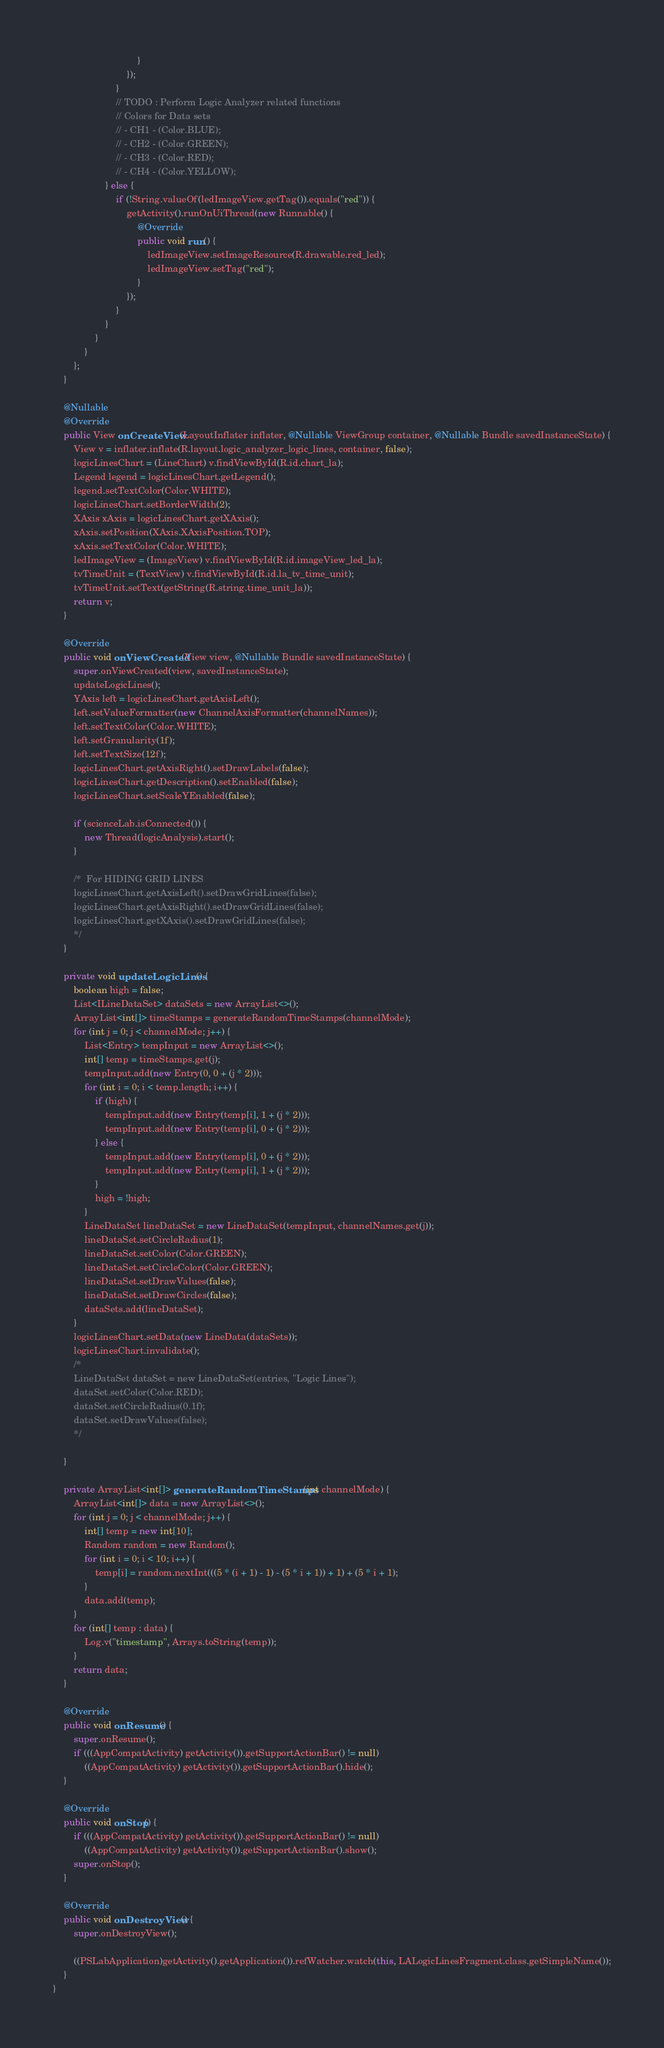<code> <loc_0><loc_0><loc_500><loc_500><_Java_>                                }
                            });
                        }
                        // TODO : Perform Logic Analyzer related functions
                        // Colors for Data sets
                        // - CH1 - (Color.BLUE);
                        // - CH2 - (Color.GREEN);
                        // - CH3 - (Color.RED);
                        // - CH4 - (Color.YELLOW);
                    } else {
                        if (!String.valueOf(ledImageView.getTag()).equals("red")) {
                            getActivity().runOnUiThread(new Runnable() {
                                @Override
                                public void run() {
                                    ledImageView.setImageResource(R.drawable.red_led);
                                    ledImageView.setTag("red");
                                }
                            });
                        }
                    }
                }
            }
        };
    }

    @Nullable
    @Override
    public View onCreateView(LayoutInflater inflater, @Nullable ViewGroup container, @Nullable Bundle savedInstanceState) {
        View v = inflater.inflate(R.layout.logic_analyzer_logic_lines, container, false);
        logicLinesChart = (LineChart) v.findViewById(R.id.chart_la);
        Legend legend = logicLinesChart.getLegend();
        legend.setTextColor(Color.WHITE);
        logicLinesChart.setBorderWidth(2);
        XAxis xAxis = logicLinesChart.getXAxis();
        xAxis.setPosition(XAxis.XAxisPosition.TOP);
        xAxis.setTextColor(Color.WHITE);
        ledImageView = (ImageView) v.findViewById(R.id.imageView_led_la);
        tvTimeUnit = (TextView) v.findViewById(R.id.la_tv_time_unit);
        tvTimeUnit.setText(getString(R.string.time_unit_la));
        return v;
    }

    @Override
    public void onViewCreated(View view, @Nullable Bundle savedInstanceState) {
        super.onViewCreated(view, savedInstanceState);
        updateLogicLines();
        YAxis left = logicLinesChart.getAxisLeft();
        left.setValueFormatter(new ChannelAxisFormatter(channelNames));
        left.setTextColor(Color.WHITE);
        left.setGranularity(1f);
        left.setTextSize(12f);
        logicLinesChart.getAxisRight().setDrawLabels(false);
        logicLinesChart.getDescription().setEnabled(false);
        logicLinesChart.setScaleYEnabled(false);

        if (scienceLab.isConnected()) {
            new Thread(logicAnalysis).start();
        }

        /*  For HIDING GRID LINES
        logicLinesChart.getAxisLeft().setDrawGridLines(false);
        logicLinesChart.getAxisRight().setDrawGridLines(false);
        logicLinesChart.getXAxis().setDrawGridLines(false);
        */
    }

    private void updateLogicLines() {
        boolean high = false;
        List<ILineDataSet> dataSets = new ArrayList<>();
        ArrayList<int[]> timeStamps = generateRandomTimeStamps(channelMode);
        for (int j = 0; j < channelMode; j++) {
            List<Entry> tempInput = new ArrayList<>();
            int[] temp = timeStamps.get(j);
            tempInput.add(new Entry(0, 0 + (j * 2)));
            for (int i = 0; i < temp.length; i++) {
                if (high) {
                    tempInput.add(new Entry(temp[i], 1 + (j * 2)));
                    tempInput.add(new Entry(temp[i], 0 + (j * 2)));
                } else {
                    tempInput.add(new Entry(temp[i], 0 + (j * 2)));
                    tempInput.add(new Entry(temp[i], 1 + (j * 2)));
                }
                high = !high;
            }
            LineDataSet lineDataSet = new LineDataSet(tempInput, channelNames.get(j));
            lineDataSet.setCircleRadius(1);
            lineDataSet.setColor(Color.GREEN);
            lineDataSet.setCircleColor(Color.GREEN);
            lineDataSet.setDrawValues(false);
            lineDataSet.setDrawCircles(false);
            dataSets.add(lineDataSet);
        }
        logicLinesChart.setData(new LineData(dataSets));
        logicLinesChart.invalidate();
        /*
        LineDataSet dataSet = new LineDataSet(entries, "Logic Lines");
        dataSet.setColor(Color.RED);
        dataSet.setCircleRadius(0.1f);
        dataSet.setDrawValues(false);
        */

    }

    private ArrayList<int[]> generateRandomTimeStamps(int channelMode) {
        ArrayList<int[]> data = new ArrayList<>();
        for (int j = 0; j < channelMode; j++) {
            int[] temp = new int[10];
            Random random = new Random();
            for (int i = 0; i < 10; i++) {
                temp[i] = random.nextInt(((5 * (i + 1) - 1) - (5 * i + 1)) + 1) + (5 * i + 1);
            }
            data.add(temp);
        }
        for (int[] temp : data) {
            Log.v("timestamp", Arrays.toString(temp));
        }
        return data;
    }

    @Override
    public void onResume() {
        super.onResume();
        if (((AppCompatActivity) getActivity()).getSupportActionBar() != null)
            ((AppCompatActivity) getActivity()).getSupportActionBar().hide();
    }

    @Override
    public void onStop() {
        if (((AppCompatActivity) getActivity()).getSupportActionBar() != null)
            ((AppCompatActivity) getActivity()).getSupportActionBar().show();
        super.onStop();
    }

    @Override
    public void onDestroyView() {
        super.onDestroyView();

        ((PSLabApplication)getActivity().getApplication()).refWatcher.watch(this, LALogicLinesFragment.class.getSimpleName());
    }
}
</code> 